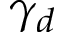<formula> <loc_0><loc_0><loc_500><loc_500>\gamma _ { d }</formula> 